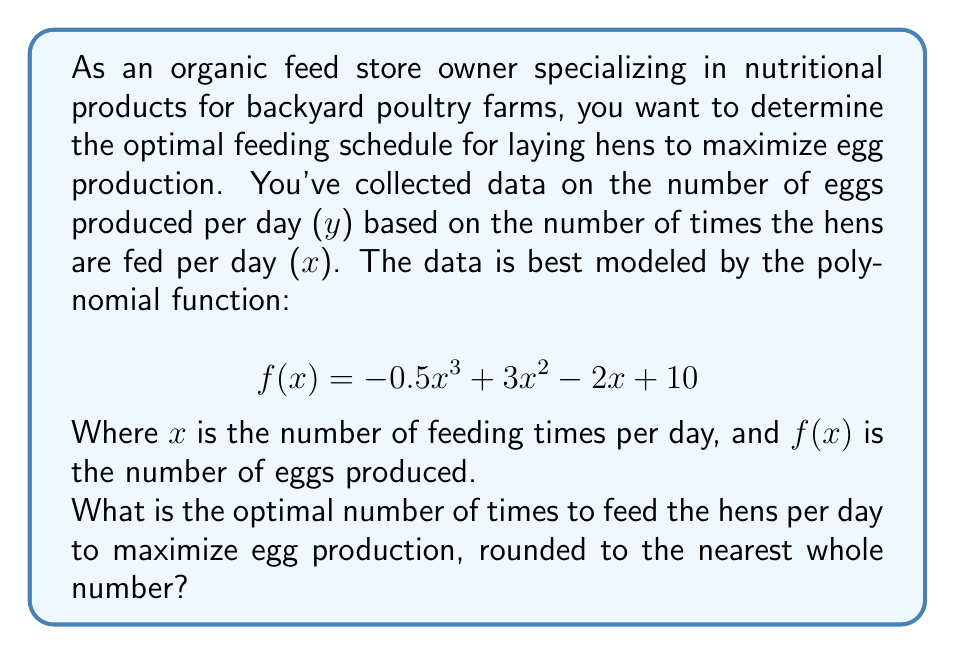Give your solution to this math problem. To find the optimal number of feeding times that maximizes egg production, we need to find the maximum point of the given polynomial function. This can be done by following these steps:

1. Find the derivative of the function:
   $$f'(x) = -1.5x^2 + 6x - 2$$

2. Set the derivative equal to zero and solve for x:
   $$-1.5x^2 + 6x - 2 = 0$$
   
   This is a quadratic equation. We can solve it using the quadratic formula:
   $$x = \frac{-b \pm \sqrt{b^2 - 4ac}}{2a}$$
   
   Where $a = -1.5$, $b = 6$, and $c = -2$

3. Plugging these values into the quadratic formula:
   $$x = \frac{-6 \pm \sqrt{6^2 - 4(-1.5)(-2)}}{2(-1.5)}$$
   $$x = \frac{-6 \pm \sqrt{36 - 12}}{-3}$$
   $$x = \frac{-6 \pm \sqrt{24}}{-3}$$
   $$x = \frac{-6 \pm 2\sqrt{6}}{-3}$$

4. This gives us two solutions:
   $$x_1 = \frac{-6 + 2\sqrt{6}}{-3} \approx 0.63$$
   $$x_2 = \frac{-6 - 2\sqrt{6}}{-3} \approx 3.37$$

5. To determine which of these is the maximum (rather than the minimum), we can check the second derivative:
   $$f''(x) = -3x + 6$$
   
   At $x = 3.37$, $f''(3.37) < 0$, indicating this is a local maximum.

6. Therefore, the optimal number of feeding times is approximately 3.37 per day.

7. Rounding to the nearest whole number gives us 3 times per day.
Answer: 3 times per day 